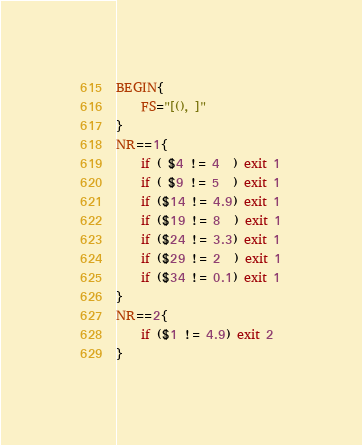<code> <loc_0><loc_0><loc_500><loc_500><_Awk_>BEGIN{
    FS="[(), ]"
}
NR==1{
    if ( $4 != 4  ) exit 1
    if ( $9 != 5  ) exit 1
    if ($14 != 4.9) exit 1
    if ($19 != 8  ) exit 1
    if ($24 != 3.3) exit 1
    if ($29 != 2  ) exit 1
    if ($34 != 0.1) exit 1
}
NR==2{
    if ($1 != 4.9) exit 2
}
</code> 